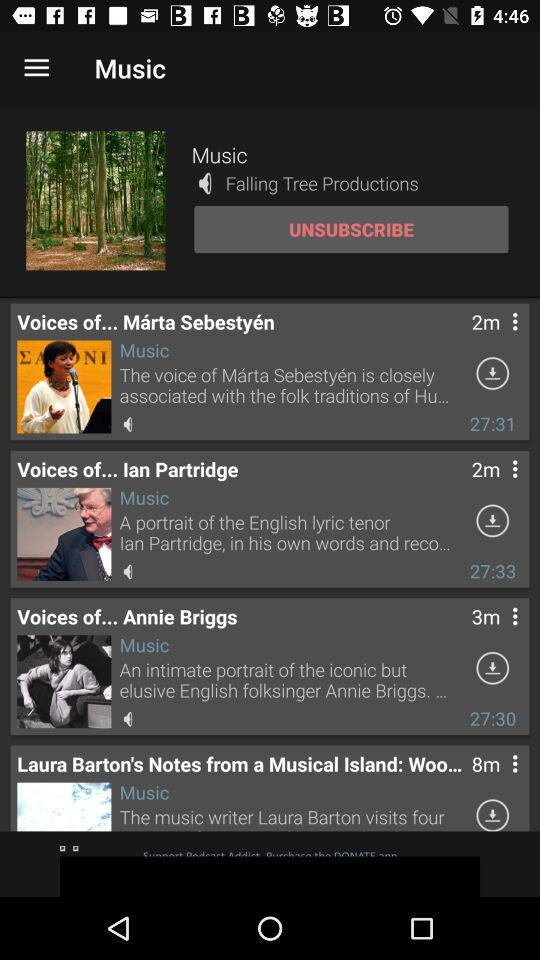Is the channel Subscribed?
When the provided information is insufficient, respond with <no answer>. <no answer> 